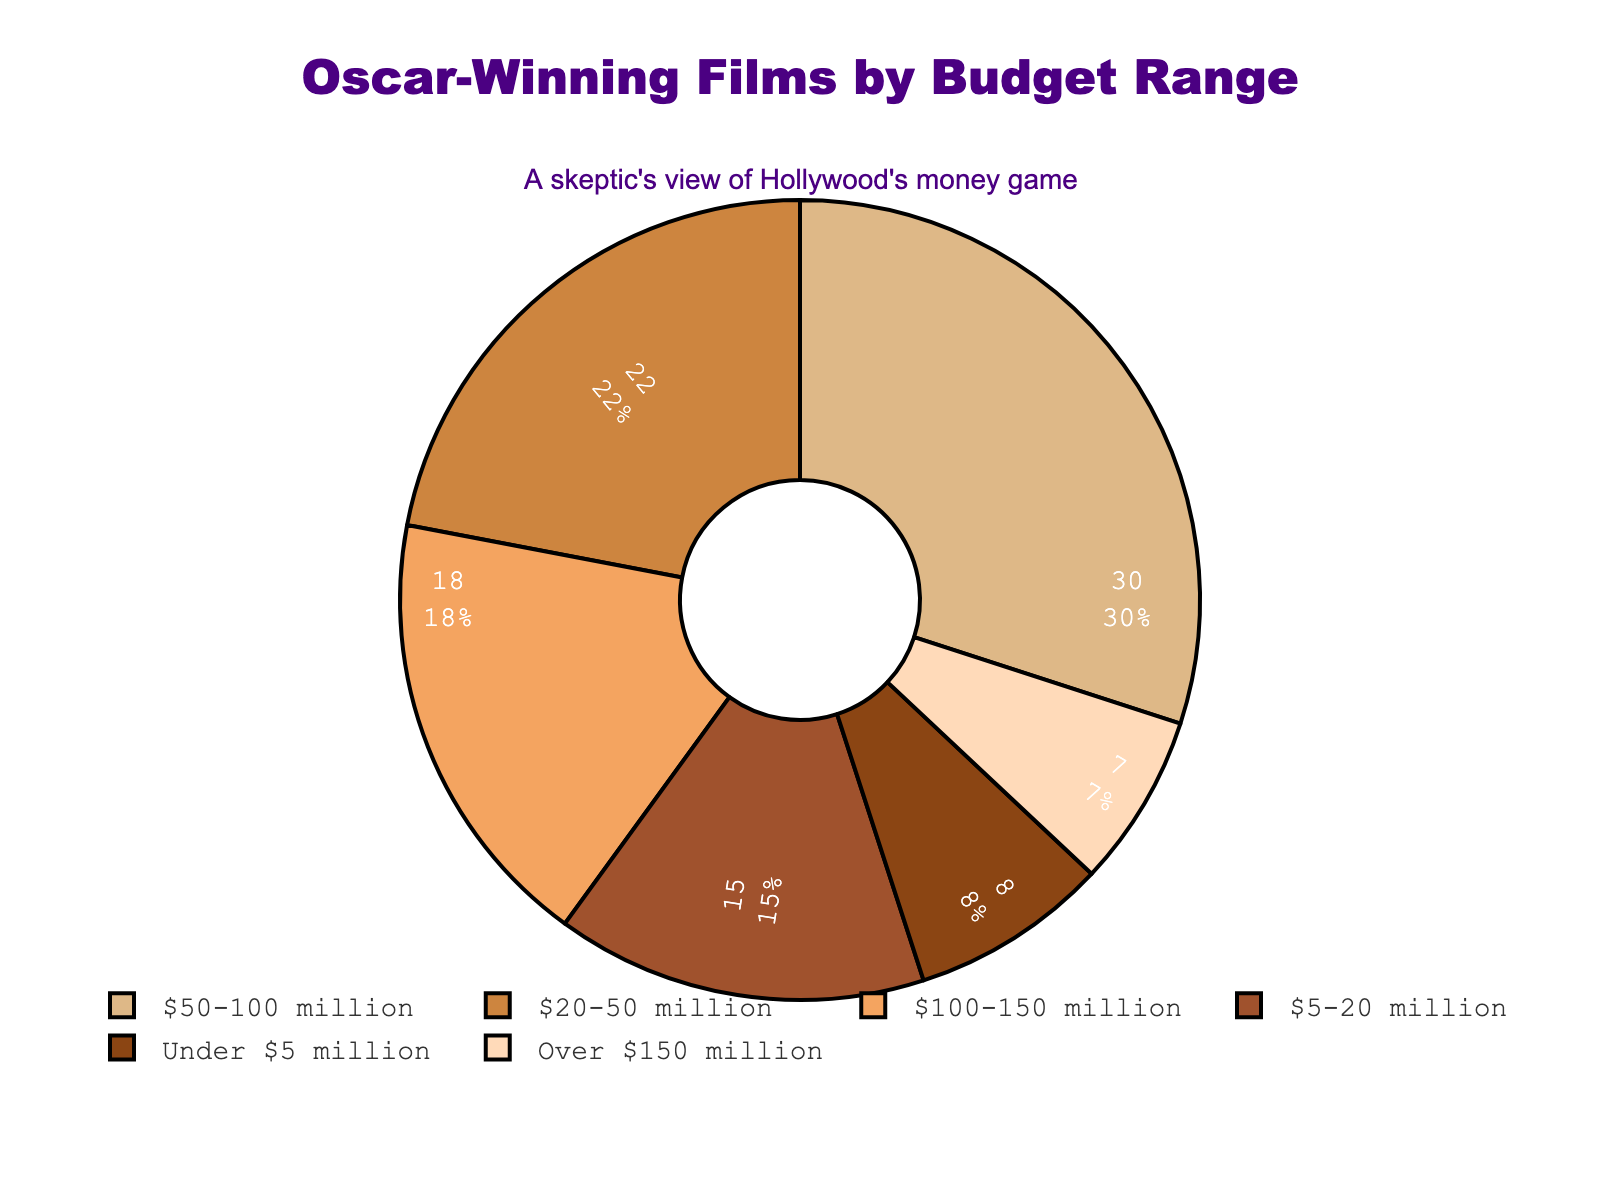What is the percentage of Oscar-winning films that had a budget under $50 million? The percentage of films with budgets under $50 million is the sum of the segments labeled 'Under $5 million', '$5-20 million', and '$20-50 million', which are 8%, 15%, and 22% respectively. Sum them: 8 + 15 + 22 = 45%
Answer: 45% Which budget range has the highest percentage of Oscar-winning films? Look for the segment with the largest percentage. The '$50-100 million' budget range has the highest percentage at 30%.
Answer: $50-100 million What is the combined percentage of Oscar-winning films with budgets over $100 million? Add the percentages for the '$100-150 million' and 'Over $150 million' budget ranges, which are 18% and 7% respectively. Sum them: 18 + 7 = 25%
Answer: 25% Which budget range has a higher percentage of Oscar-winning films: '$5-20 million' or 'Over $150 million'? Compare the percentages of the '$5-20 million' and 'Over $150 million' ranges, which are 15% and 7% respectively. 15% is higher than 7%.
Answer: $5-20 million What is the difference in percentage between the highest and lowest budget range categories? Subtract the percentage of the lowest budget range ('Over $150 million' at 7%) from the highest budget range ('$50-100 million' at 30%). Difference: 30 - 7 = 23%
Answer: 23% What proportion of the total do the 'Under $5 million' and '$100-150 million' budget ranges represent together? Add the percentages for the 'Under $5 million' (8%) and '$100-150 million' (18%) categories. Sum them: 8 + 18 = 26%
Answer: 26% Is the percentage of Oscar-winning films with a budget between $20 million and $50 million higher or lower than the percentage with a budget between $100 million and $150 million? Compare the percentages of the '$20-50 million' (22%) and '$100-150 million' (18%) categories. 22% is higher than 18%.
Answer: Higher 